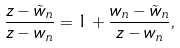Convert formula to latex. <formula><loc_0><loc_0><loc_500><loc_500>\frac { z - \tilde { w } _ { n } } { z - w _ { n } } = 1 + \frac { w _ { n } - \tilde { w } _ { n } } { z - w _ { n } } ,</formula> 